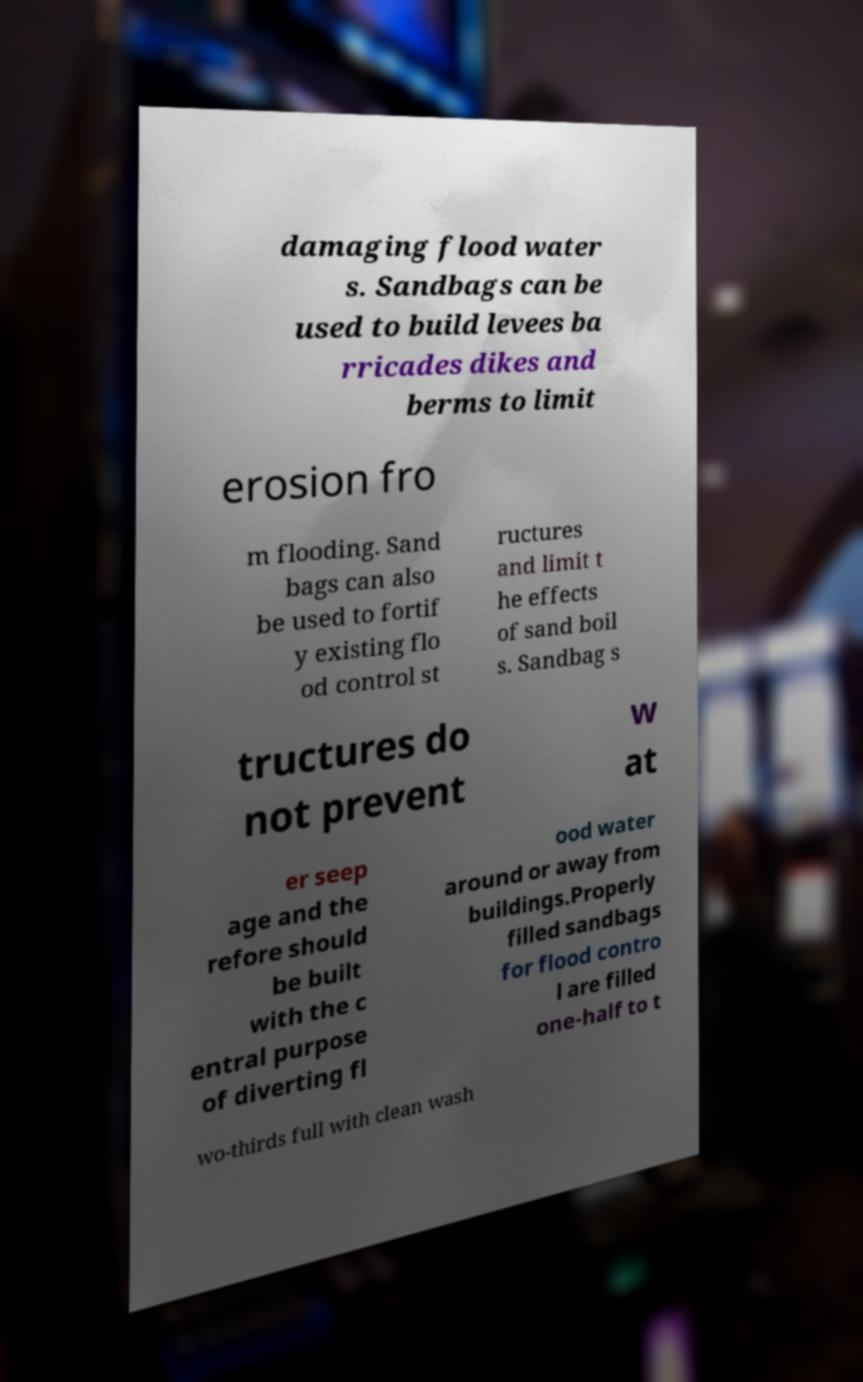Could you assist in decoding the text presented in this image and type it out clearly? damaging flood water s. Sandbags can be used to build levees ba rricades dikes and berms to limit erosion fro m flooding. Sand bags can also be used to fortif y existing flo od control st ructures and limit t he effects of sand boil s. Sandbag s tructures do not prevent w at er seep age and the refore should be built with the c entral purpose of diverting fl ood water around or away from buildings.Properly filled sandbags for flood contro l are filled one-half to t wo-thirds full with clean wash 